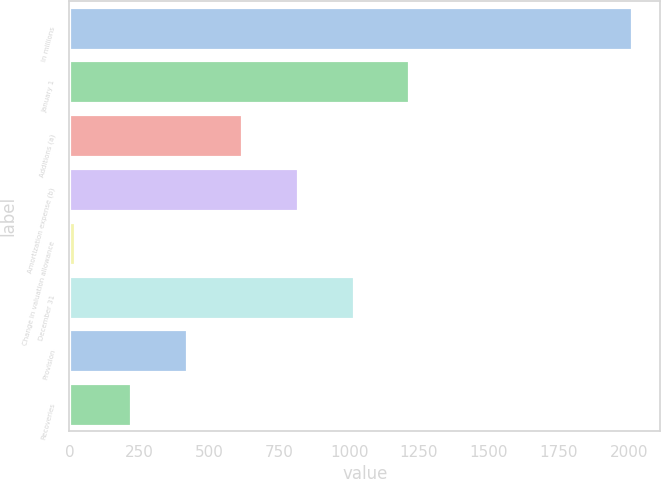Convert chart. <chart><loc_0><loc_0><loc_500><loc_500><bar_chart><fcel>In millions<fcel>January 1<fcel>Additions (a)<fcel>Amortization expense (b)<fcel>Change in valuation allowance<fcel>December 31<fcel>Provision<fcel>Recoveries<nl><fcel>2012<fcel>1215.6<fcel>618.3<fcel>817.4<fcel>21<fcel>1016.5<fcel>419.2<fcel>220.1<nl></chart> 